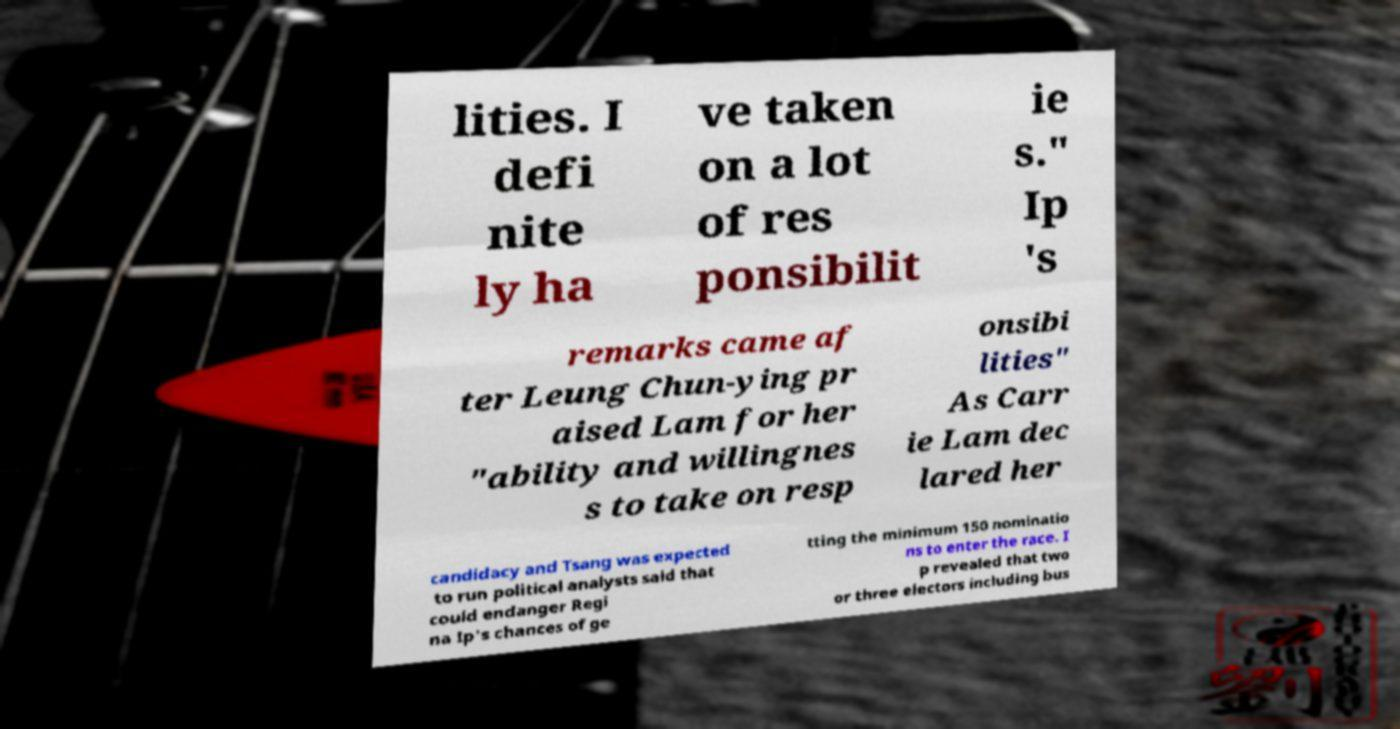Can you read and provide the text displayed in the image?This photo seems to have some interesting text. Can you extract and type it out for me? lities. I defi nite ly ha ve taken on a lot of res ponsibilit ie s." Ip 's remarks came af ter Leung Chun-ying pr aised Lam for her "ability and willingnes s to take on resp onsibi lities" As Carr ie Lam dec lared her candidacy and Tsang was expected to run political analysts said that could endanger Regi na Ip's chances of ge tting the minimum 150 nominatio ns to enter the race. I p revealed that two or three electors including bus 